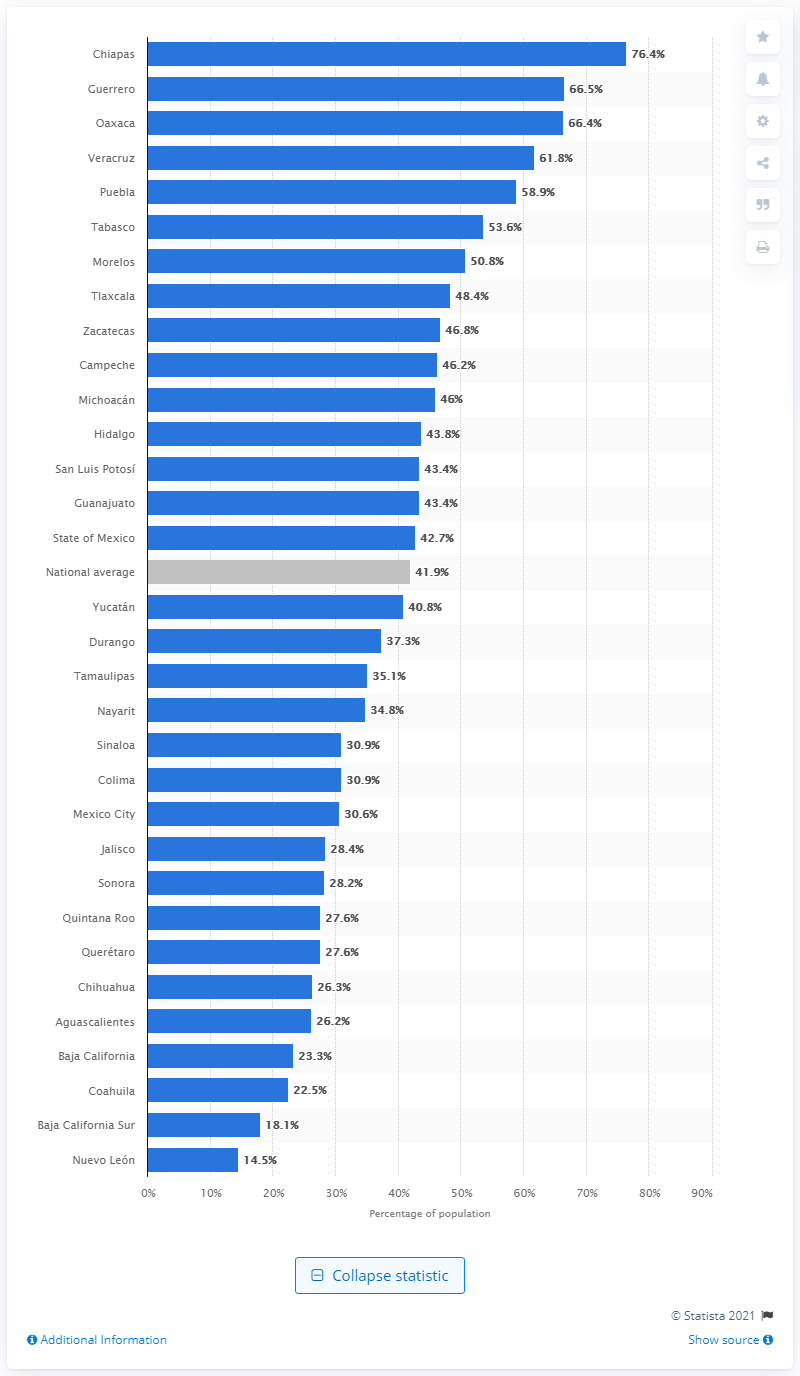Give some essential details in this illustration. In 2018, Chiapas had the highest poverty rate among all states in Mexico. 